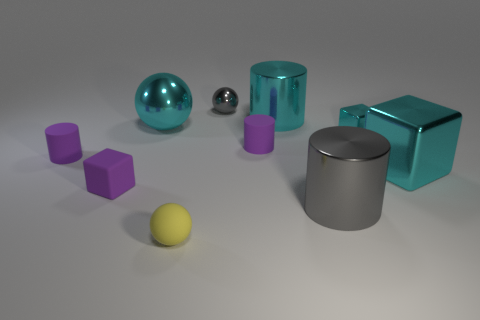What is the size of the cylinder that is the same color as the large sphere?
Your answer should be compact. Large. There is a tiny thing that is both in front of the large metallic block and behind the small yellow matte ball; what color is it?
Make the answer very short. Purple. There is a gray metal thing that is in front of the cyan cube on the left side of the large cyan cube; is there a small gray sphere right of it?
Your answer should be very brief. No. There is a yellow thing that is the same shape as the small gray shiny object; what is its size?
Your answer should be very brief. Small. Is there anything else that has the same material as the gray sphere?
Offer a terse response. Yes. Are any yellow matte spheres visible?
Offer a very short reply. Yes. There is a tiny metallic block; is its color the same as the metal ball that is left of the tiny rubber ball?
Your answer should be very brief. Yes. How big is the cyan shiny thing that is on the left side of the purple cylinder to the right of the gray metallic object that is behind the large cyan metallic sphere?
Ensure brevity in your answer.  Large. What number of things are the same color as the small matte block?
Offer a very short reply. 2. How many things are either tiny rubber things or big cyan metallic things to the left of the small shiny sphere?
Provide a succinct answer. 5. 